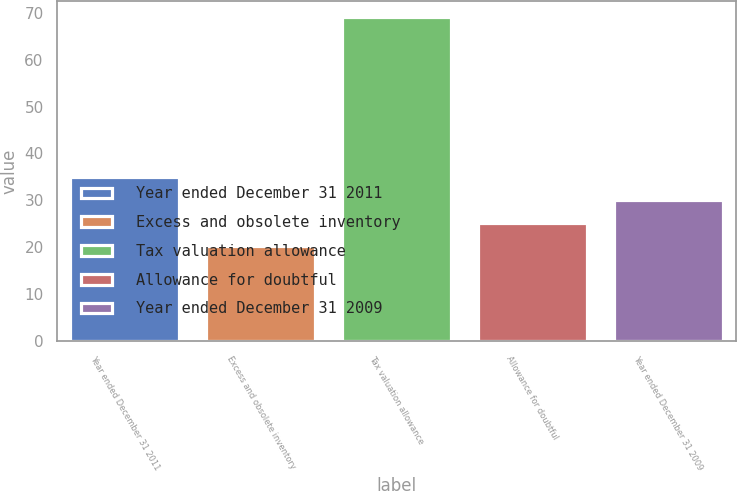<chart> <loc_0><loc_0><loc_500><loc_500><bar_chart><fcel>Year ended December 31 2011<fcel>Excess and obsolete inventory<fcel>Tax valuation allowance<fcel>Allowance for doubtful<fcel>Year ended December 31 2009<nl><fcel>34.87<fcel>20.2<fcel>69.1<fcel>25.09<fcel>29.98<nl></chart> 